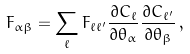<formula> <loc_0><loc_0><loc_500><loc_500>F _ { \alpha \beta } = \sum _ { \ell } F _ { \ell \ell ^ { \prime } } \frac { \partial C _ { \ell } } { \partial \theta _ { \alpha } } \frac { \partial C _ { \ell ^ { \prime } } } { \partial \theta _ { \beta } } \, ,</formula> 